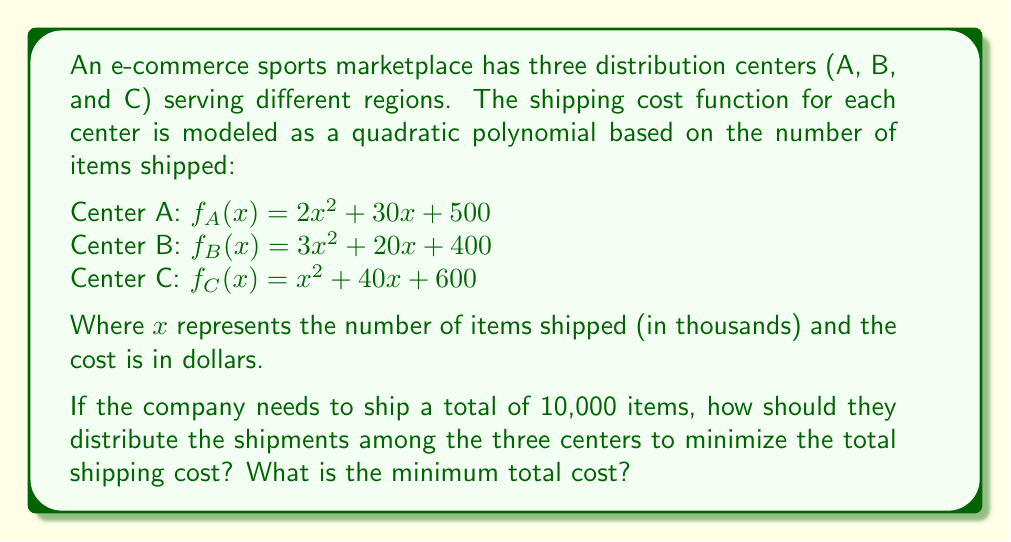What is the answer to this math problem? To solve this optimization problem, we need to use polynomial optimization techniques. Let's approach this step-by-step:

1) Let $a$, $b$, and $c$ represent the number of items (in thousands) shipped from centers A, B, and C respectively.

2) We need to minimize the total cost function:
   $T(a,b,c) = f_A(a) + f_B(b) + f_C(c)$
   $= (2a^2 + 30a + 500) + (3b^2 + 20b + 400) + (c^2 + 40c + 600)$

3) Subject to the constraint:
   $a + b + c = 10$ (since total items to be shipped is 10,000)

4) We can use the method of Lagrange multipliers. Let's define:
   $L(a,b,c,λ) = T(a,b,c) - λ(a + b + c - 10)$

5) Now, we set the partial derivatives to zero:

   $\frac{\partial L}{\partial a} = 4a + 30 - λ = 0$
   $\frac{\partial L}{\partial b} = 6b + 20 - λ = 0$
   $\frac{\partial L}{\partial c} = 2c + 40 - λ = 0$
   $\frac{\partial L}{\partial λ} = a + b + c - 10 = 0$

6) From these equations:
   $a = \frac{λ - 30}{4}$
   $b = \frac{λ - 20}{6}$
   $c = \frac{λ - 40}{2}$

7) Substituting these into the constraint equation:
   $\frac{λ - 30}{4} + \frac{λ - 20}{6} + \frac{λ - 40}{2} = 10$

8) Solving this equation:
   $\frac{3(λ - 30)}{12} + \frac{2(λ - 20)}{12} + \frac{6(λ - 40)}{12} = 10$
   $11λ - 330 - 40 - 240 = 120$
   $11λ = 730$
   $λ = 66.36$

9) Now we can find $a$, $b$, and $c$:
   $a = \frac{66.36 - 30}{4} = 9.09$
   $b = \frac{66.36 - 20}{6} = 7.73$
   $c = \frac{66.36 - 40}{2} = 13.18$

10) Rounding to the nearest whole number of items:
    $a = 9,090$ items
    $b = 7,730$ items
    $c = 13,180$ items

11) The total cost is:
    $T = f_A(9.09) + f_B(7.73) + f_C(13.18)$
    $= (2(9.09)^2 + 30(9.09) + 500) + (3(7.73)^2 + 20(7.73) + 400) + ((13.18)^2 + 40(13.18) + 600)$
    $= 1,137.22 + 1,055.37 + 1,304.52$
    $= 3,497.11$
Answer: The optimal distribution of shipments is approximately:
Center A: 9,090 items
Center B: 7,730 items
Center C: 13,180 items

The minimum total shipping cost is $3,497.11. 